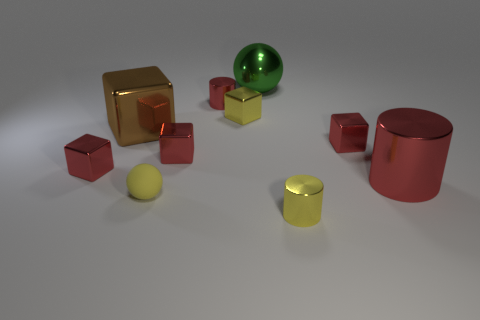Are there any other things that are made of the same material as the yellow ball?
Provide a succinct answer. No. What is the shape of the large thing behind the small red object behind the big block?
Offer a terse response. Sphere. How many red blocks are on the right side of the yellow ball?
Your response must be concise. 2. Is the yellow cube made of the same material as the cylinder that is behind the large red cylinder?
Ensure brevity in your answer.  Yes. Is there a matte object that has the same size as the yellow rubber sphere?
Give a very brief answer. No. Is the number of small red cylinders in front of the matte thing the same as the number of balls?
Provide a succinct answer. No. The yellow matte ball has what size?
Keep it short and to the point. Small. What number of small yellow objects are in front of the cube on the right side of the small yellow cube?
Make the answer very short. 2. The metal thing that is left of the yellow sphere and in front of the big brown shiny thing has what shape?
Your answer should be very brief. Cube. What number of other small objects are the same color as the rubber thing?
Ensure brevity in your answer.  2. 